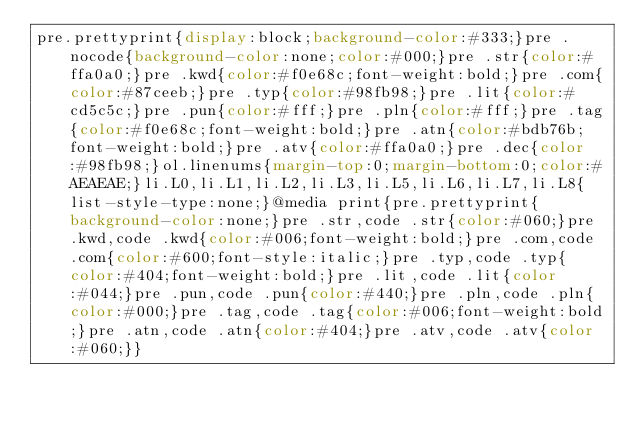Convert code to text. <code><loc_0><loc_0><loc_500><loc_500><_CSS_>pre.prettyprint{display:block;background-color:#333;}pre .nocode{background-color:none;color:#000;}pre .str{color:#ffa0a0;}pre .kwd{color:#f0e68c;font-weight:bold;}pre .com{color:#87ceeb;}pre .typ{color:#98fb98;}pre .lit{color:#cd5c5c;}pre .pun{color:#fff;}pre .pln{color:#fff;}pre .tag{color:#f0e68c;font-weight:bold;}pre .atn{color:#bdb76b;font-weight:bold;}pre .atv{color:#ffa0a0;}pre .dec{color:#98fb98;}ol.linenums{margin-top:0;margin-bottom:0;color:#AEAEAE;}li.L0,li.L1,li.L2,li.L3,li.L5,li.L6,li.L7,li.L8{list-style-type:none;}@media print{pre.prettyprint{background-color:none;}pre .str,code .str{color:#060;}pre .kwd,code .kwd{color:#006;font-weight:bold;}pre .com,code .com{color:#600;font-style:italic;}pre .typ,code .typ{color:#404;font-weight:bold;}pre .lit,code .lit{color:#044;}pre .pun,code .pun{color:#440;}pre .pln,code .pln{color:#000;}pre .tag,code .tag{color:#006;font-weight:bold;}pre .atn,code .atn{color:#404;}pre .atv,code .atv{color:#060;}}</code> 